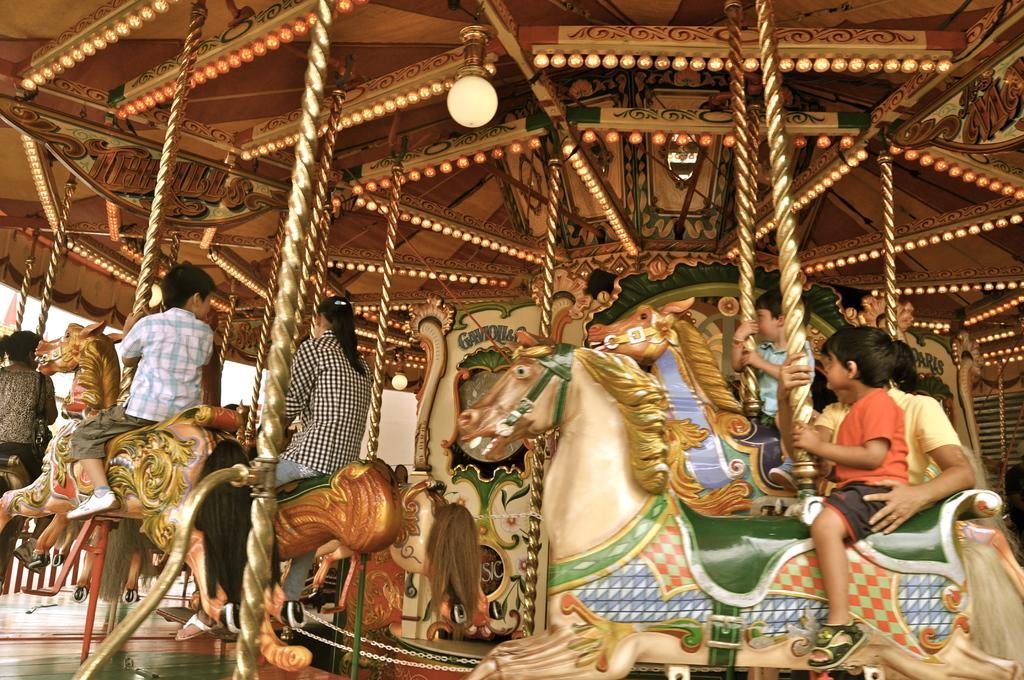How would you summarize this image in a sentence or two? This is an amusement ride where we can see few persons are riding on the toy horses and there is a light on the roof top and in the background there are objects. 